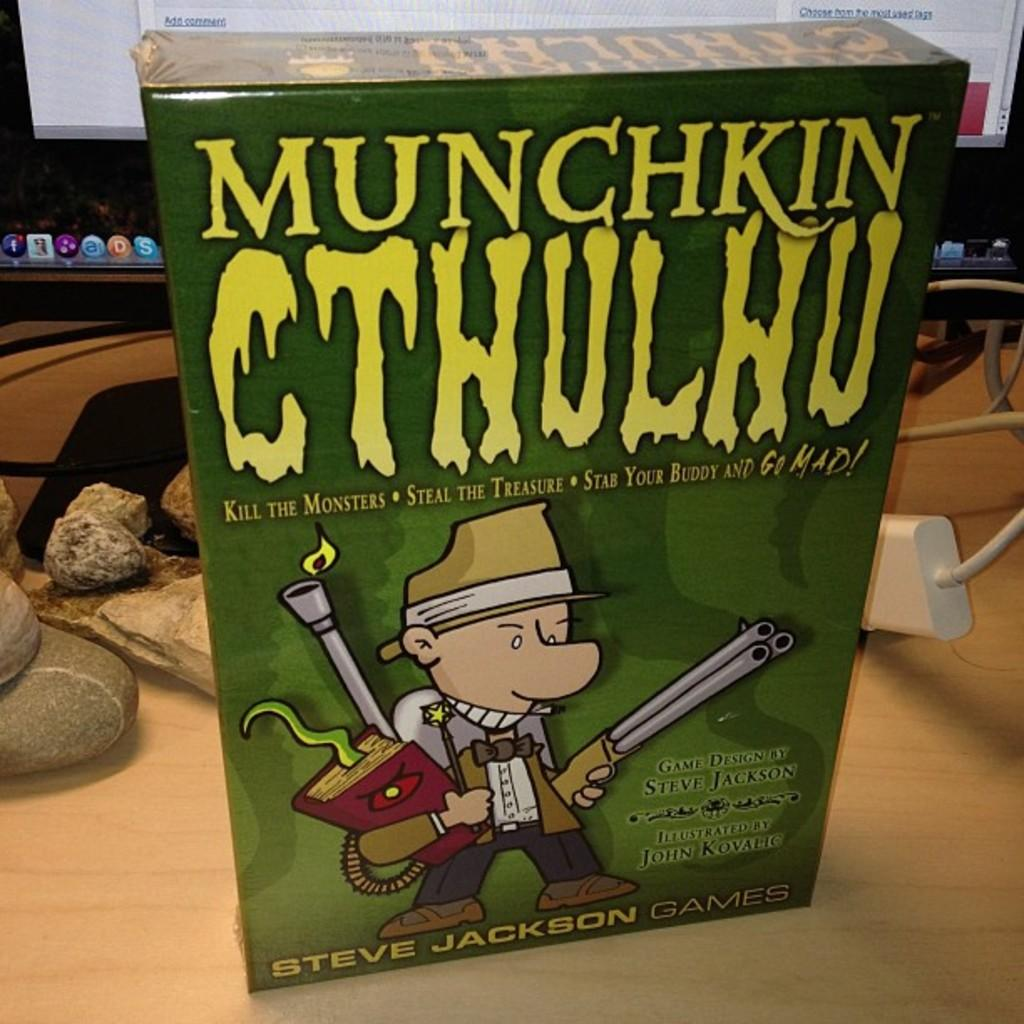<image>
Share a concise interpretation of the image provided. A game by Steve Jackson that features the drawing of a person holding a gun and red book. 